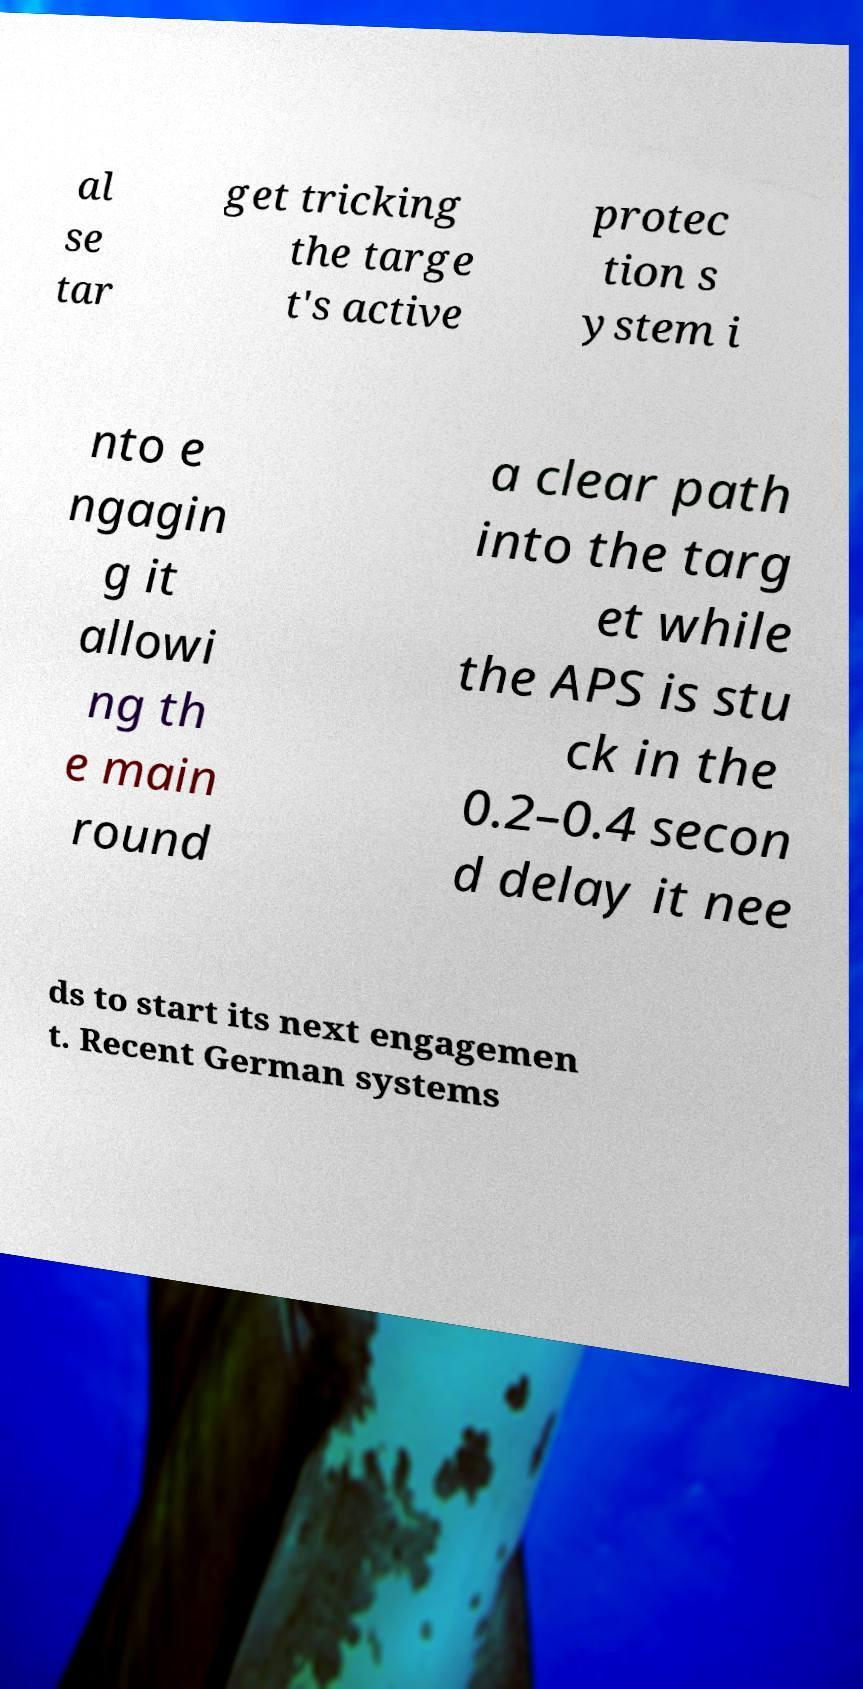Could you extract and type out the text from this image? al se tar get tricking the targe t's active protec tion s ystem i nto e ngagin g it allowi ng th e main round a clear path into the targ et while the APS is stu ck in the 0.2–0.4 secon d delay it nee ds to start its next engagemen t. Recent German systems 